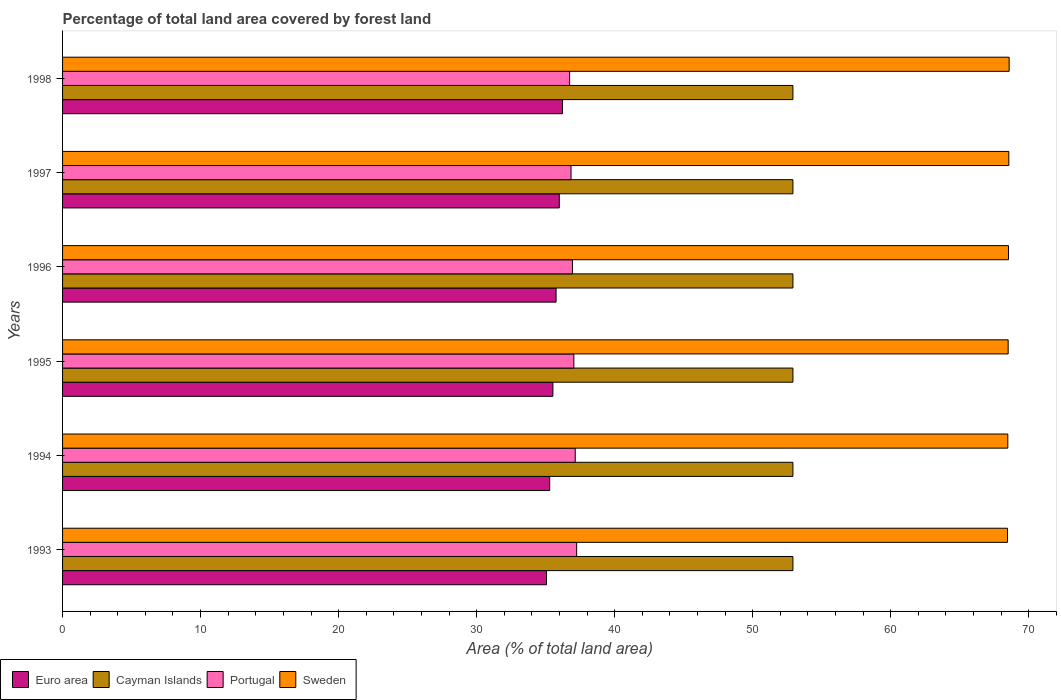How many different coloured bars are there?
Offer a terse response. 4. Are the number of bars per tick equal to the number of legend labels?
Offer a very short reply. Yes. Are the number of bars on each tick of the Y-axis equal?
Provide a succinct answer. Yes. In how many cases, is the number of bars for a given year not equal to the number of legend labels?
Make the answer very short. 0. What is the percentage of forest land in Portugal in 1994?
Your answer should be very brief. 37.15. Across all years, what is the maximum percentage of forest land in Sweden?
Make the answer very short. 68.58. Across all years, what is the minimum percentage of forest land in Euro area?
Provide a short and direct response. 35.06. In which year was the percentage of forest land in Sweden maximum?
Your answer should be compact. 1998. What is the total percentage of forest land in Euro area in the graph?
Offer a terse response. 213.85. What is the difference between the percentage of forest land in Portugal in 1995 and the percentage of forest land in Sweden in 1998?
Your answer should be compact. -31.54. What is the average percentage of forest land in Cayman Islands per year?
Provide a short and direct response. 52.92. In the year 1993, what is the difference between the percentage of forest land in Portugal and percentage of forest land in Cayman Islands?
Ensure brevity in your answer.  -15.67. In how many years, is the percentage of forest land in Portugal greater than 12 %?
Make the answer very short. 6. What is the ratio of the percentage of forest land in Portugal in 1997 to that in 1998?
Your response must be concise. 1. What is the difference between the highest and the second highest percentage of forest land in Portugal?
Offer a terse response. 0.1. What is the difference between the highest and the lowest percentage of forest land in Sweden?
Ensure brevity in your answer.  0.12. In how many years, is the percentage of forest land in Portugal greater than the average percentage of forest land in Portugal taken over all years?
Your answer should be very brief. 3. Is the sum of the percentage of forest land in Sweden in 1993 and 1997 greater than the maximum percentage of forest land in Cayman Islands across all years?
Make the answer very short. Yes. Is it the case that in every year, the sum of the percentage of forest land in Sweden and percentage of forest land in Cayman Islands is greater than the sum of percentage of forest land in Portugal and percentage of forest land in Euro area?
Your response must be concise. Yes. What does the 4th bar from the bottom in 1993 represents?
Make the answer very short. Sweden. Is it the case that in every year, the sum of the percentage of forest land in Cayman Islands and percentage of forest land in Sweden is greater than the percentage of forest land in Portugal?
Your answer should be very brief. Yes. Are the values on the major ticks of X-axis written in scientific E-notation?
Offer a terse response. No. Does the graph contain any zero values?
Make the answer very short. No. Does the graph contain grids?
Offer a terse response. No. Where does the legend appear in the graph?
Make the answer very short. Bottom left. What is the title of the graph?
Your answer should be compact. Percentage of total land area covered by forest land. What is the label or title of the X-axis?
Provide a short and direct response. Area (% of total land area). What is the label or title of the Y-axis?
Your response must be concise. Years. What is the Area (% of total land area) in Euro area in 1993?
Your answer should be very brief. 35.06. What is the Area (% of total land area) in Cayman Islands in 1993?
Provide a succinct answer. 52.92. What is the Area (% of total land area) of Portugal in 1993?
Offer a very short reply. 37.25. What is the Area (% of total land area) in Sweden in 1993?
Keep it short and to the point. 68.46. What is the Area (% of total land area) of Euro area in 1994?
Your answer should be compact. 35.29. What is the Area (% of total land area) of Cayman Islands in 1994?
Your answer should be very brief. 52.92. What is the Area (% of total land area) of Portugal in 1994?
Your response must be concise. 37.15. What is the Area (% of total land area) in Sweden in 1994?
Offer a very short reply. 68.49. What is the Area (% of total land area) in Euro area in 1995?
Your response must be concise. 35.53. What is the Area (% of total land area) in Cayman Islands in 1995?
Make the answer very short. 52.92. What is the Area (% of total land area) of Portugal in 1995?
Make the answer very short. 37.04. What is the Area (% of total land area) of Sweden in 1995?
Keep it short and to the point. 68.51. What is the Area (% of total land area) of Euro area in 1996?
Keep it short and to the point. 35.76. What is the Area (% of total land area) in Cayman Islands in 1996?
Your response must be concise. 52.92. What is the Area (% of total land area) of Portugal in 1996?
Your answer should be very brief. 36.94. What is the Area (% of total land area) of Sweden in 1996?
Offer a terse response. 68.54. What is the Area (% of total land area) in Euro area in 1997?
Your answer should be very brief. 35.99. What is the Area (% of total land area) in Cayman Islands in 1997?
Make the answer very short. 52.92. What is the Area (% of total land area) of Portugal in 1997?
Give a very brief answer. 36.84. What is the Area (% of total land area) of Sweden in 1997?
Offer a terse response. 68.56. What is the Area (% of total land area) of Euro area in 1998?
Offer a terse response. 36.22. What is the Area (% of total land area) of Cayman Islands in 1998?
Give a very brief answer. 52.92. What is the Area (% of total land area) of Portugal in 1998?
Keep it short and to the point. 36.74. What is the Area (% of total land area) of Sweden in 1998?
Provide a short and direct response. 68.58. Across all years, what is the maximum Area (% of total land area) in Euro area?
Provide a succinct answer. 36.22. Across all years, what is the maximum Area (% of total land area) of Cayman Islands?
Make the answer very short. 52.92. Across all years, what is the maximum Area (% of total land area) of Portugal?
Your response must be concise. 37.25. Across all years, what is the maximum Area (% of total land area) of Sweden?
Ensure brevity in your answer.  68.58. Across all years, what is the minimum Area (% of total land area) in Euro area?
Your answer should be very brief. 35.06. Across all years, what is the minimum Area (% of total land area) of Cayman Islands?
Provide a short and direct response. 52.92. Across all years, what is the minimum Area (% of total land area) of Portugal?
Your answer should be compact. 36.74. Across all years, what is the minimum Area (% of total land area) in Sweden?
Offer a very short reply. 68.46. What is the total Area (% of total land area) in Euro area in the graph?
Ensure brevity in your answer.  213.85. What is the total Area (% of total land area) in Cayman Islands in the graph?
Provide a short and direct response. 317.5. What is the total Area (% of total land area) of Portugal in the graph?
Make the answer very short. 221.96. What is the total Area (% of total land area) in Sweden in the graph?
Ensure brevity in your answer.  411.14. What is the difference between the Area (% of total land area) of Euro area in 1993 and that in 1994?
Your answer should be very brief. -0.23. What is the difference between the Area (% of total land area) in Cayman Islands in 1993 and that in 1994?
Keep it short and to the point. 0. What is the difference between the Area (% of total land area) of Portugal in 1993 and that in 1994?
Make the answer very short. 0.1. What is the difference between the Area (% of total land area) of Sweden in 1993 and that in 1994?
Provide a short and direct response. -0.02. What is the difference between the Area (% of total land area) of Euro area in 1993 and that in 1995?
Provide a succinct answer. -0.46. What is the difference between the Area (% of total land area) in Portugal in 1993 and that in 1995?
Keep it short and to the point. 0.2. What is the difference between the Area (% of total land area) in Sweden in 1993 and that in 1995?
Provide a succinct answer. -0.05. What is the difference between the Area (% of total land area) of Euro area in 1993 and that in 1996?
Ensure brevity in your answer.  -0.69. What is the difference between the Area (% of total land area) of Portugal in 1993 and that in 1996?
Your response must be concise. 0.3. What is the difference between the Area (% of total land area) of Sweden in 1993 and that in 1996?
Give a very brief answer. -0.07. What is the difference between the Area (% of total land area) of Euro area in 1993 and that in 1997?
Give a very brief answer. -0.93. What is the difference between the Area (% of total land area) of Cayman Islands in 1993 and that in 1997?
Make the answer very short. 0. What is the difference between the Area (% of total land area) of Portugal in 1993 and that in 1997?
Your answer should be very brief. 0.41. What is the difference between the Area (% of total land area) of Sweden in 1993 and that in 1997?
Provide a succinct answer. -0.1. What is the difference between the Area (% of total land area) in Euro area in 1993 and that in 1998?
Offer a very short reply. -1.16. What is the difference between the Area (% of total land area) in Portugal in 1993 and that in 1998?
Make the answer very short. 0.51. What is the difference between the Area (% of total land area) of Sweden in 1993 and that in 1998?
Make the answer very short. -0.12. What is the difference between the Area (% of total land area) in Euro area in 1994 and that in 1995?
Keep it short and to the point. -0.23. What is the difference between the Area (% of total land area) in Portugal in 1994 and that in 1995?
Your answer should be compact. 0.1. What is the difference between the Area (% of total land area) of Sweden in 1994 and that in 1995?
Offer a very short reply. -0.02. What is the difference between the Area (% of total land area) of Euro area in 1994 and that in 1996?
Your answer should be compact. -0.46. What is the difference between the Area (% of total land area) in Cayman Islands in 1994 and that in 1996?
Offer a very short reply. 0. What is the difference between the Area (% of total land area) of Portugal in 1994 and that in 1996?
Offer a terse response. 0.2. What is the difference between the Area (% of total land area) in Sweden in 1994 and that in 1996?
Make the answer very short. -0.05. What is the difference between the Area (% of total land area) of Euro area in 1994 and that in 1997?
Provide a short and direct response. -0.69. What is the difference between the Area (% of total land area) of Cayman Islands in 1994 and that in 1997?
Your response must be concise. 0. What is the difference between the Area (% of total land area) of Portugal in 1994 and that in 1997?
Your answer should be compact. 0.3. What is the difference between the Area (% of total land area) in Sweden in 1994 and that in 1997?
Give a very brief answer. -0.07. What is the difference between the Area (% of total land area) in Euro area in 1994 and that in 1998?
Keep it short and to the point. -0.93. What is the difference between the Area (% of total land area) in Cayman Islands in 1994 and that in 1998?
Offer a very short reply. 0. What is the difference between the Area (% of total land area) of Portugal in 1994 and that in 1998?
Your answer should be compact. 0.41. What is the difference between the Area (% of total land area) in Sweden in 1994 and that in 1998?
Your answer should be compact. -0.1. What is the difference between the Area (% of total land area) in Euro area in 1995 and that in 1996?
Make the answer very short. -0.23. What is the difference between the Area (% of total land area) in Cayman Islands in 1995 and that in 1996?
Provide a short and direct response. 0. What is the difference between the Area (% of total land area) of Portugal in 1995 and that in 1996?
Provide a succinct answer. 0.1. What is the difference between the Area (% of total land area) of Sweden in 1995 and that in 1996?
Your response must be concise. -0.02. What is the difference between the Area (% of total land area) in Euro area in 1995 and that in 1997?
Your response must be concise. -0.46. What is the difference between the Area (% of total land area) of Portugal in 1995 and that in 1997?
Your answer should be very brief. 0.2. What is the difference between the Area (% of total land area) in Sweden in 1995 and that in 1997?
Keep it short and to the point. -0.05. What is the difference between the Area (% of total land area) of Euro area in 1995 and that in 1998?
Make the answer very short. -0.69. What is the difference between the Area (% of total land area) in Portugal in 1995 and that in 1998?
Provide a short and direct response. 0.3. What is the difference between the Area (% of total land area) of Sweden in 1995 and that in 1998?
Your response must be concise. -0.07. What is the difference between the Area (% of total land area) of Euro area in 1996 and that in 1997?
Provide a succinct answer. -0.23. What is the difference between the Area (% of total land area) in Portugal in 1996 and that in 1997?
Provide a short and direct response. 0.1. What is the difference between the Area (% of total land area) in Sweden in 1996 and that in 1997?
Provide a succinct answer. -0.02. What is the difference between the Area (% of total land area) in Euro area in 1996 and that in 1998?
Keep it short and to the point. -0.46. What is the difference between the Area (% of total land area) in Cayman Islands in 1996 and that in 1998?
Make the answer very short. 0. What is the difference between the Area (% of total land area) in Portugal in 1996 and that in 1998?
Provide a succinct answer. 0.2. What is the difference between the Area (% of total land area) of Sweden in 1996 and that in 1998?
Ensure brevity in your answer.  -0.05. What is the difference between the Area (% of total land area) of Euro area in 1997 and that in 1998?
Your answer should be very brief. -0.23. What is the difference between the Area (% of total land area) in Portugal in 1997 and that in 1998?
Make the answer very short. 0.1. What is the difference between the Area (% of total land area) in Sweden in 1997 and that in 1998?
Your answer should be very brief. -0.02. What is the difference between the Area (% of total land area) in Euro area in 1993 and the Area (% of total land area) in Cayman Islands in 1994?
Provide a succinct answer. -17.85. What is the difference between the Area (% of total land area) of Euro area in 1993 and the Area (% of total land area) of Portugal in 1994?
Provide a succinct answer. -2.08. What is the difference between the Area (% of total land area) of Euro area in 1993 and the Area (% of total land area) of Sweden in 1994?
Your answer should be very brief. -33.42. What is the difference between the Area (% of total land area) in Cayman Islands in 1993 and the Area (% of total land area) in Portugal in 1994?
Offer a terse response. 15.77. What is the difference between the Area (% of total land area) in Cayman Islands in 1993 and the Area (% of total land area) in Sweden in 1994?
Give a very brief answer. -15.57. What is the difference between the Area (% of total land area) in Portugal in 1993 and the Area (% of total land area) in Sweden in 1994?
Your response must be concise. -31.24. What is the difference between the Area (% of total land area) of Euro area in 1993 and the Area (% of total land area) of Cayman Islands in 1995?
Give a very brief answer. -17.85. What is the difference between the Area (% of total land area) of Euro area in 1993 and the Area (% of total land area) of Portugal in 1995?
Your answer should be compact. -1.98. What is the difference between the Area (% of total land area) of Euro area in 1993 and the Area (% of total land area) of Sweden in 1995?
Your response must be concise. -33.45. What is the difference between the Area (% of total land area) in Cayman Islands in 1993 and the Area (% of total land area) in Portugal in 1995?
Ensure brevity in your answer.  15.87. What is the difference between the Area (% of total land area) of Cayman Islands in 1993 and the Area (% of total land area) of Sweden in 1995?
Your answer should be compact. -15.59. What is the difference between the Area (% of total land area) of Portugal in 1993 and the Area (% of total land area) of Sweden in 1995?
Give a very brief answer. -31.26. What is the difference between the Area (% of total land area) in Euro area in 1993 and the Area (% of total land area) in Cayman Islands in 1996?
Make the answer very short. -17.85. What is the difference between the Area (% of total land area) in Euro area in 1993 and the Area (% of total land area) in Portugal in 1996?
Your answer should be compact. -1.88. What is the difference between the Area (% of total land area) in Euro area in 1993 and the Area (% of total land area) in Sweden in 1996?
Your response must be concise. -33.47. What is the difference between the Area (% of total land area) in Cayman Islands in 1993 and the Area (% of total land area) in Portugal in 1996?
Make the answer very short. 15.97. What is the difference between the Area (% of total land area) in Cayman Islands in 1993 and the Area (% of total land area) in Sweden in 1996?
Make the answer very short. -15.62. What is the difference between the Area (% of total land area) of Portugal in 1993 and the Area (% of total land area) of Sweden in 1996?
Offer a very short reply. -31.29. What is the difference between the Area (% of total land area) in Euro area in 1993 and the Area (% of total land area) in Cayman Islands in 1997?
Keep it short and to the point. -17.85. What is the difference between the Area (% of total land area) of Euro area in 1993 and the Area (% of total land area) of Portugal in 1997?
Your response must be concise. -1.78. What is the difference between the Area (% of total land area) of Euro area in 1993 and the Area (% of total land area) of Sweden in 1997?
Your response must be concise. -33.5. What is the difference between the Area (% of total land area) of Cayman Islands in 1993 and the Area (% of total land area) of Portugal in 1997?
Your answer should be compact. 16.08. What is the difference between the Area (% of total land area) in Cayman Islands in 1993 and the Area (% of total land area) in Sweden in 1997?
Provide a succinct answer. -15.64. What is the difference between the Area (% of total land area) of Portugal in 1993 and the Area (% of total land area) of Sweden in 1997?
Your answer should be compact. -31.31. What is the difference between the Area (% of total land area) of Euro area in 1993 and the Area (% of total land area) of Cayman Islands in 1998?
Your answer should be compact. -17.85. What is the difference between the Area (% of total land area) of Euro area in 1993 and the Area (% of total land area) of Portugal in 1998?
Provide a succinct answer. -1.68. What is the difference between the Area (% of total land area) in Euro area in 1993 and the Area (% of total land area) in Sweden in 1998?
Keep it short and to the point. -33.52. What is the difference between the Area (% of total land area) in Cayman Islands in 1993 and the Area (% of total land area) in Portugal in 1998?
Keep it short and to the point. 16.18. What is the difference between the Area (% of total land area) in Cayman Islands in 1993 and the Area (% of total land area) in Sweden in 1998?
Your answer should be very brief. -15.67. What is the difference between the Area (% of total land area) in Portugal in 1993 and the Area (% of total land area) in Sweden in 1998?
Provide a short and direct response. -31.34. What is the difference between the Area (% of total land area) in Euro area in 1994 and the Area (% of total land area) in Cayman Islands in 1995?
Provide a short and direct response. -17.62. What is the difference between the Area (% of total land area) in Euro area in 1994 and the Area (% of total land area) in Portugal in 1995?
Your response must be concise. -1.75. What is the difference between the Area (% of total land area) in Euro area in 1994 and the Area (% of total land area) in Sweden in 1995?
Provide a succinct answer. -33.22. What is the difference between the Area (% of total land area) in Cayman Islands in 1994 and the Area (% of total land area) in Portugal in 1995?
Your answer should be compact. 15.87. What is the difference between the Area (% of total land area) of Cayman Islands in 1994 and the Area (% of total land area) of Sweden in 1995?
Keep it short and to the point. -15.59. What is the difference between the Area (% of total land area) of Portugal in 1994 and the Area (% of total land area) of Sweden in 1995?
Offer a terse response. -31.37. What is the difference between the Area (% of total land area) of Euro area in 1994 and the Area (% of total land area) of Cayman Islands in 1996?
Provide a succinct answer. -17.62. What is the difference between the Area (% of total land area) of Euro area in 1994 and the Area (% of total land area) of Portugal in 1996?
Provide a succinct answer. -1.65. What is the difference between the Area (% of total land area) of Euro area in 1994 and the Area (% of total land area) of Sweden in 1996?
Give a very brief answer. -33.24. What is the difference between the Area (% of total land area) in Cayman Islands in 1994 and the Area (% of total land area) in Portugal in 1996?
Your answer should be compact. 15.97. What is the difference between the Area (% of total land area) of Cayman Islands in 1994 and the Area (% of total land area) of Sweden in 1996?
Make the answer very short. -15.62. What is the difference between the Area (% of total land area) of Portugal in 1994 and the Area (% of total land area) of Sweden in 1996?
Make the answer very short. -31.39. What is the difference between the Area (% of total land area) of Euro area in 1994 and the Area (% of total land area) of Cayman Islands in 1997?
Your answer should be compact. -17.62. What is the difference between the Area (% of total land area) in Euro area in 1994 and the Area (% of total land area) in Portugal in 1997?
Provide a succinct answer. -1.55. What is the difference between the Area (% of total land area) of Euro area in 1994 and the Area (% of total land area) of Sweden in 1997?
Offer a terse response. -33.27. What is the difference between the Area (% of total land area) of Cayman Islands in 1994 and the Area (% of total land area) of Portugal in 1997?
Offer a very short reply. 16.08. What is the difference between the Area (% of total land area) of Cayman Islands in 1994 and the Area (% of total land area) of Sweden in 1997?
Provide a succinct answer. -15.64. What is the difference between the Area (% of total land area) of Portugal in 1994 and the Area (% of total land area) of Sweden in 1997?
Ensure brevity in your answer.  -31.41. What is the difference between the Area (% of total land area) of Euro area in 1994 and the Area (% of total land area) of Cayman Islands in 1998?
Ensure brevity in your answer.  -17.62. What is the difference between the Area (% of total land area) of Euro area in 1994 and the Area (% of total land area) of Portugal in 1998?
Provide a short and direct response. -1.44. What is the difference between the Area (% of total land area) in Euro area in 1994 and the Area (% of total land area) in Sweden in 1998?
Offer a very short reply. -33.29. What is the difference between the Area (% of total land area) of Cayman Islands in 1994 and the Area (% of total land area) of Portugal in 1998?
Keep it short and to the point. 16.18. What is the difference between the Area (% of total land area) in Cayman Islands in 1994 and the Area (% of total land area) in Sweden in 1998?
Provide a short and direct response. -15.67. What is the difference between the Area (% of total land area) of Portugal in 1994 and the Area (% of total land area) of Sweden in 1998?
Make the answer very short. -31.44. What is the difference between the Area (% of total land area) in Euro area in 1995 and the Area (% of total land area) in Cayman Islands in 1996?
Ensure brevity in your answer.  -17.39. What is the difference between the Area (% of total land area) of Euro area in 1995 and the Area (% of total land area) of Portugal in 1996?
Give a very brief answer. -1.42. What is the difference between the Area (% of total land area) of Euro area in 1995 and the Area (% of total land area) of Sweden in 1996?
Provide a short and direct response. -33.01. What is the difference between the Area (% of total land area) of Cayman Islands in 1995 and the Area (% of total land area) of Portugal in 1996?
Your answer should be very brief. 15.97. What is the difference between the Area (% of total land area) of Cayman Islands in 1995 and the Area (% of total land area) of Sweden in 1996?
Ensure brevity in your answer.  -15.62. What is the difference between the Area (% of total land area) of Portugal in 1995 and the Area (% of total land area) of Sweden in 1996?
Your response must be concise. -31.49. What is the difference between the Area (% of total land area) of Euro area in 1995 and the Area (% of total land area) of Cayman Islands in 1997?
Offer a terse response. -17.39. What is the difference between the Area (% of total land area) in Euro area in 1995 and the Area (% of total land area) in Portugal in 1997?
Offer a very short reply. -1.31. What is the difference between the Area (% of total land area) in Euro area in 1995 and the Area (% of total land area) in Sweden in 1997?
Keep it short and to the point. -33.03. What is the difference between the Area (% of total land area) in Cayman Islands in 1995 and the Area (% of total land area) in Portugal in 1997?
Provide a short and direct response. 16.08. What is the difference between the Area (% of total land area) of Cayman Islands in 1995 and the Area (% of total land area) of Sweden in 1997?
Provide a succinct answer. -15.64. What is the difference between the Area (% of total land area) in Portugal in 1995 and the Area (% of total land area) in Sweden in 1997?
Offer a very short reply. -31.52. What is the difference between the Area (% of total land area) in Euro area in 1995 and the Area (% of total land area) in Cayman Islands in 1998?
Your answer should be very brief. -17.39. What is the difference between the Area (% of total land area) of Euro area in 1995 and the Area (% of total land area) of Portugal in 1998?
Ensure brevity in your answer.  -1.21. What is the difference between the Area (% of total land area) in Euro area in 1995 and the Area (% of total land area) in Sweden in 1998?
Offer a terse response. -33.06. What is the difference between the Area (% of total land area) of Cayman Islands in 1995 and the Area (% of total land area) of Portugal in 1998?
Offer a terse response. 16.18. What is the difference between the Area (% of total land area) of Cayman Islands in 1995 and the Area (% of total land area) of Sweden in 1998?
Provide a succinct answer. -15.67. What is the difference between the Area (% of total land area) in Portugal in 1995 and the Area (% of total land area) in Sweden in 1998?
Ensure brevity in your answer.  -31.54. What is the difference between the Area (% of total land area) of Euro area in 1996 and the Area (% of total land area) of Cayman Islands in 1997?
Keep it short and to the point. -17.16. What is the difference between the Area (% of total land area) in Euro area in 1996 and the Area (% of total land area) in Portugal in 1997?
Keep it short and to the point. -1.08. What is the difference between the Area (% of total land area) in Euro area in 1996 and the Area (% of total land area) in Sweden in 1997?
Provide a short and direct response. -32.8. What is the difference between the Area (% of total land area) of Cayman Islands in 1996 and the Area (% of total land area) of Portugal in 1997?
Keep it short and to the point. 16.08. What is the difference between the Area (% of total land area) in Cayman Islands in 1996 and the Area (% of total land area) in Sweden in 1997?
Your answer should be very brief. -15.64. What is the difference between the Area (% of total land area) in Portugal in 1996 and the Area (% of total land area) in Sweden in 1997?
Provide a succinct answer. -31.62. What is the difference between the Area (% of total land area) in Euro area in 1996 and the Area (% of total land area) in Cayman Islands in 1998?
Offer a terse response. -17.16. What is the difference between the Area (% of total land area) in Euro area in 1996 and the Area (% of total land area) in Portugal in 1998?
Offer a very short reply. -0.98. What is the difference between the Area (% of total land area) of Euro area in 1996 and the Area (% of total land area) of Sweden in 1998?
Offer a terse response. -32.83. What is the difference between the Area (% of total land area) in Cayman Islands in 1996 and the Area (% of total land area) in Portugal in 1998?
Ensure brevity in your answer.  16.18. What is the difference between the Area (% of total land area) in Cayman Islands in 1996 and the Area (% of total land area) in Sweden in 1998?
Provide a short and direct response. -15.67. What is the difference between the Area (% of total land area) in Portugal in 1996 and the Area (% of total land area) in Sweden in 1998?
Your answer should be compact. -31.64. What is the difference between the Area (% of total land area) of Euro area in 1997 and the Area (% of total land area) of Cayman Islands in 1998?
Provide a short and direct response. -16.93. What is the difference between the Area (% of total land area) of Euro area in 1997 and the Area (% of total land area) of Portugal in 1998?
Give a very brief answer. -0.75. What is the difference between the Area (% of total land area) in Euro area in 1997 and the Area (% of total land area) in Sweden in 1998?
Your response must be concise. -32.6. What is the difference between the Area (% of total land area) of Cayman Islands in 1997 and the Area (% of total land area) of Portugal in 1998?
Ensure brevity in your answer.  16.18. What is the difference between the Area (% of total land area) in Cayman Islands in 1997 and the Area (% of total land area) in Sweden in 1998?
Your response must be concise. -15.67. What is the difference between the Area (% of total land area) of Portugal in 1997 and the Area (% of total land area) of Sweden in 1998?
Keep it short and to the point. -31.74. What is the average Area (% of total land area) in Euro area per year?
Give a very brief answer. 35.64. What is the average Area (% of total land area) of Cayman Islands per year?
Your answer should be very brief. 52.92. What is the average Area (% of total land area) in Portugal per year?
Ensure brevity in your answer.  36.99. What is the average Area (% of total land area) in Sweden per year?
Offer a very short reply. 68.52. In the year 1993, what is the difference between the Area (% of total land area) in Euro area and Area (% of total land area) in Cayman Islands?
Your answer should be very brief. -17.85. In the year 1993, what is the difference between the Area (% of total land area) in Euro area and Area (% of total land area) in Portugal?
Provide a short and direct response. -2.18. In the year 1993, what is the difference between the Area (% of total land area) in Euro area and Area (% of total land area) in Sweden?
Provide a succinct answer. -33.4. In the year 1993, what is the difference between the Area (% of total land area) in Cayman Islands and Area (% of total land area) in Portugal?
Your answer should be very brief. 15.67. In the year 1993, what is the difference between the Area (% of total land area) in Cayman Islands and Area (% of total land area) in Sweden?
Your answer should be very brief. -15.55. In the year 1993, what is the difference between the Area (% of total land area) of Portugal and Area (% of total land area) of Sweden?
Your answer should be very brief. -31.22. In the year 1994, what is the difference between the Area (% of total land area) of Euro area and Area (% of total land area) of Cayman Islands?
Provide a short and direct response. -17.62. In the year 1994, what is the difference between the Area (% of total land area) in Euro area and Area (% of total land area) in Portugal?
Your answer should be very brief. -1.85. In the year 1994, what is the difference between the Area (% of total land area) of Euro area and Area (% of total land area) of Sweden?
Your answer should be compact. -33.19. In the year 1994, what is the difference between the Area (% of total land area) in Cayman Islands and Area (% of total land area) in Portugal?
Your answer should be compact. 15.77. In the year 1994, what is the difference between the Area (% of total land area) in Cayman Islands and Area (% of total land area) in Sweden?
Provide a succinct answer. -15.57. In the year 1994, what is the difference between the Area (% of total land area) of Portugal and Area (% of total land area) of Sweden?
Keep it short and to the point. -31.34. In the year 1995, what is the difference between the Area (% of total land area) of Euro area and Area (% of total land area) of Cayman Islands?
Your response must be concise. -17.39. In the year 1995, what is the difference between the Area (% of total land area) of Euro area and Area (% of total land area) of Portugal?
Your answer should be compact. -1.52. In the year 1995, what is the difference between the Area (% of total land area) in Euro area and Area (% of total land area) in Sweden?
Your response must be concise. -32.99. In the year 1995, what is the difference between the Area (% of total land area) in Cayman Islands and Area (% of total land area) in Portugal?
Your answer should be compact. 15.87. In the year 1995, what is the difference between the Area (% of total land area) of Cayman Islands and Area (% of total land area) of Sweden?
Make the answer very short. -15.59. In the year 1995, what is the difference between the Area (% of total land area) of Portugal and Area (% of total land area) of Sweden?
Provide a short and direct response. -31.47. In the year 1996, what is the difference between the Area (% of total land area) in Euro area and Area (% of total land area) in Cayman Islands?
Offer a terse response. -17.16. In the year 1996, what is the difference between the Area (% of total land area) of Euro area and Area (% of total land area) of Portugal?
Your response must be concise. -1.18. In the year 1996, what is the difference between the Area (% of total land area) in Euro area and Area (% of total land area) in Sweden?
Make the answer very short. -32.78. In the year 1996, what is the difference between the Area (% of total land area) in Cayman Islands and Area (% of total land area) in Portugal?
Your answer should be compact. 15.97. In the year 1996, what is the difference between the Area (% of total land area) of Cayman Islands and Area (% of total land area) of Sweden?
Provide a short and direct response. -15.62. In the year 1996, what is the difference between the Area (% of total land area) of Portugal and Area (% of total land area) of Sweden?
Ensure brevity in your answer.  -31.59. In the year 1997, what is the difference between the Area (% of total land area) of Euro area and Area (% of total land area) of Cayman Islands?
Your response must be concise. -16.93. In the year 1997, what is the difference between the Area (% of total land area) of Euro area and Area (% of total land area) of Portugal?
Your answer should be very brief. -0.85. In the year 1997, what is the difference between the Area (% of total land area) in Euro area and Area (% of total land area) in Sweden?
Your response must be concise. -32.57. In the year 1997, what is the difference between the Area (% of total land area) of Cayman Islands and Area (% of total land area) of Portugal?
Ensure brevity in your answer.  16.08. In the year 1997, what is the difference between the Area (% of total land area) of Cayman Islands and Area (% of total land area) of Sweden?
Make the answer very short. -15.64. In the year 1997, what is the difference between the Area (% of total land area) in Portugal and Area (% of total land area) in Sweden?
Give a very brief answer. -31.72. In the year 1998, what is the difference between the Area (% of total land area) in Euro area and Area (% of total land area) in Cayman Islands?
Ensure brevity in your answer.  -16.7. In the year 1998, what is the difference between the Area (% of total land area) in Euro area and Area (% of total land area) in Portugal?
Make the answer very short. -0.52. In the year 1998, what is the difference between the Area (% of total land area) of Euro area and Area (% of total land area) of Sweden?
Your response must be concise. -32.36. In the year 1998, what is the difference between the Area (% of total land area) in Cayman Islands and Area (% of total land area) in Portugal?
Give a very brief answer. 16.18. In the year 1998, what is the difference between the Area (% of total land area) of Cayman Islands and Area (% of total land area) of Sweden?
Ensure brevity in your answer.  -15.67. In the year 1998, what is the difference between the Area (% of total land area) in Portugal and Area (% of total land area) in Sweden?
Provide a succinct answer. -31.85. What is the ratio of the Area (% of total land area) of Cayman Islands in 1993 to that in 1994?
Keep it short and to the point. 1. What is the ratio of the Area (% of total land area) in Sweden in 1993 to that in 1994?
Make the answer very short. 1. What is the ratio of the Area (% of total land area) of Euro area in 1993 to that in 1995?
Make the answer very short. 0.99. What is the ratio of the Area (% of total land area) in Portugal in 1993 to that in 1995?
Offer a terse response. 1.01. What is the ratio of the Area (% of total land area) in Euro area in 1993 to that in 1996?
Make the answer very short. 0.98. What is the ratio of the Area (% of total land area) in Cayman Islands in 1993 to that in 1996?
Offer a terse response. 1. What is the ratio of the Area (% of total land area) in Portugal in 1993 to that in 1996?
Offer a very short reply. 1.01. What is the ratio of the Area (% of total land area) of Euro area in 1993 to that in 1997?
Keep it short and to the point. 0.97. What is the ratio of the Area (% of total land area) in Cayman Islands in 1993 to that in 1997?
Offer a terse response. 1. What is the ratio of the Area (% of total land area) in Portugal in 1993 to that in 1997?
Provide a short and direct response. 1.01. What is the ratio of the Area (% of total land area) in Sweden in 1993 to that in 1997?
Your response must be concise. 1. What is the ratio of the Area (% of total land area) of Euro area in 1993 to that in 1998?
Offer a terse response. 0.97. What is the ratio of the Area (% of total land area) in Cayman Islands in 1993 to that in 1998?
Keep it short and to the point. 1. What is the ratio of the Area (% of total land area) in Portugal in 1993 to that in 1998?
Ensure brevity in your answer.  1.01. What is the ratio of the Area (% of total land area) of Euro area in 1994 to that in 1995?
Give a very brief answer. 0.99. What is the ratio of the Area (% of total land area) in Cayman Islands in 1994 to that in 1995?
Your response must be concise. 1. What is the ratio of the Area (% of total land area) in Euro area in 1994 to that in 1996?
Your answer should be very brief. 0.99. What is the ratio of the Area (% of total land area) of Portugal in 1994 to that in 1996?
Keep it short and to the point. 1.01. What is the ratio of the Area (% of total land area) in Euro area in 1994 to that in 1997?
Offer a very short reply. 0.98. What is the ratio of the Area (% of total land area) of Cayman Islands in 1994 to that in 1997?
Keep it short and to the point. 1. What is the ratio of the Area (% of total land area) in Portugal in 1994 to that in 1997?
Provide a short and direct response. 1.01. What is the ratio of the Area (% of total land area) in Euro area in 1994 to that in 1998?
Provide a short and direct response. 0.97. What is the ratio of the Area (% of total land area) of Portugal in 1994 to that in 1998?
Provide a succinct answer. 1.01. What is the ratio of the Area (% of total land area) of Euro area in 1995 to that in 1996?
Make the answer very short. 0.99. What is the ratio of the Area (% of total land area) of Euro area in 1995 to that in 1997?
Your answer should be very brief. 0.99. What is the ratio of the Area (% of total land area) in Cayman Islands in 1995 to that in 1997?
Your answer should be compact. 1. What is the ratio of the Area (% of total land area) of Portugal in 1995 to that in 1997?
Make the answer very short. 1.01. What is the ratio of the Area (% of total land area) in Euro area in 1995 to that in 1998?
Your response must be concise. 0.98. What is the ratio of the Area (% of total land area) of Portugal in 1995 to that in 1998?
Make the answer very short. 1.01. What is the ratio of the Area (% of total land area) of Cayman Islands in 1996 to that in 1997?
Keep it short and to the point. 1. What is the ratio of the Area (% of total land area) of Portugal in 1996 to that in 1997?
Offer a terse response. 1. What is the ratio of the Area (% of total land area) of Sweden in 1996 to that in 1997?
Your answer should be very brief. 1. What is the ratio of the Area (% of total land area) in Euro area in 1996 to that in 1998?
Ensure brevity in your answer.  0.99. What is the ratio of the Area (% of total land area) of Portugal in 1996 to that in 1998?
Give a very brief answer. 1.01. What is the ratio of the Area (% of total land area) of Sweden in 1996 to that in 1998?
Your response must be concise. 1. What is the ratio of the Area (% of total land area) of Euro area in 1997 to that in 1998?
Your response must be concise. 0.99. What is the ratio of the Area (% of total land area) in Sweden in 1997 to that in 1998?
Offer a terse response. 1. What is the difference between the highest and the second highest Area (% of total land area) of Euro area?
Make the answer very short. 0.23. What is the difference between the highest and the second highest Area (% of total land area) of Cayman Islands?
Your answer should be compact. 0. What is the difference between the highest and the second highest Area (% of total land area) in Portugal?
Provide a succinct answer. 0.1. What is the difference between the highest and the second highest Area (% of total land area) in Sweden?
Keep it short and to the point. 0.02. What is the difference between the highest and the lowest Area (% of total land area) in Euro area?
Your answer should be very brief. 1.16. What is the difference between the highest and the lowest Area (% of total land area) of Portugal?
Keep it short and to the point. 0.51. What is the difference between the highest and the lowest Area (% of total land area) in Sweden?
Your answer should be compact. 0.12. 